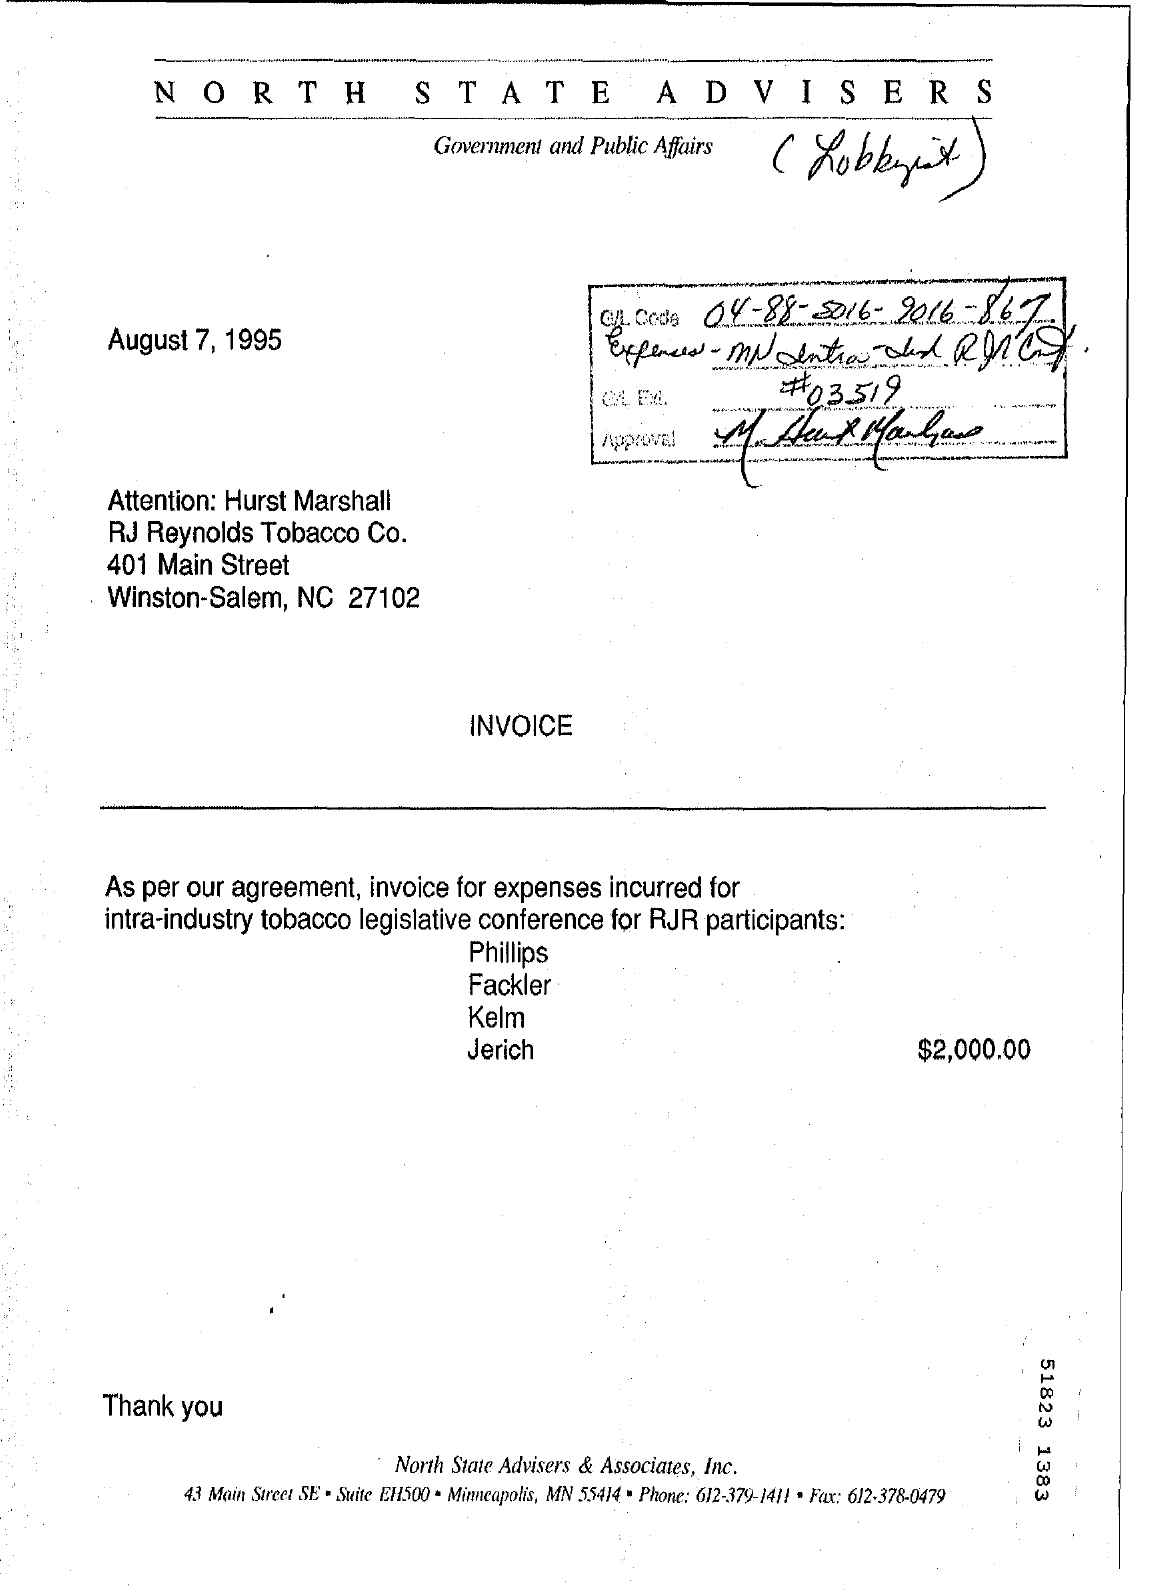What is the date in the invoice?
Your response must be concise. August 7, 1995. What is the name of the company?
Ensure brevity in your answer.  RJ Reynolds Tobacco Co. 